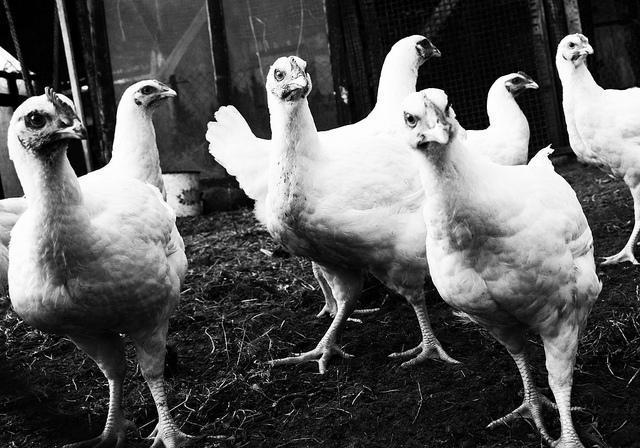How many birds are in the picture?
Give a very brief answer. 7. 